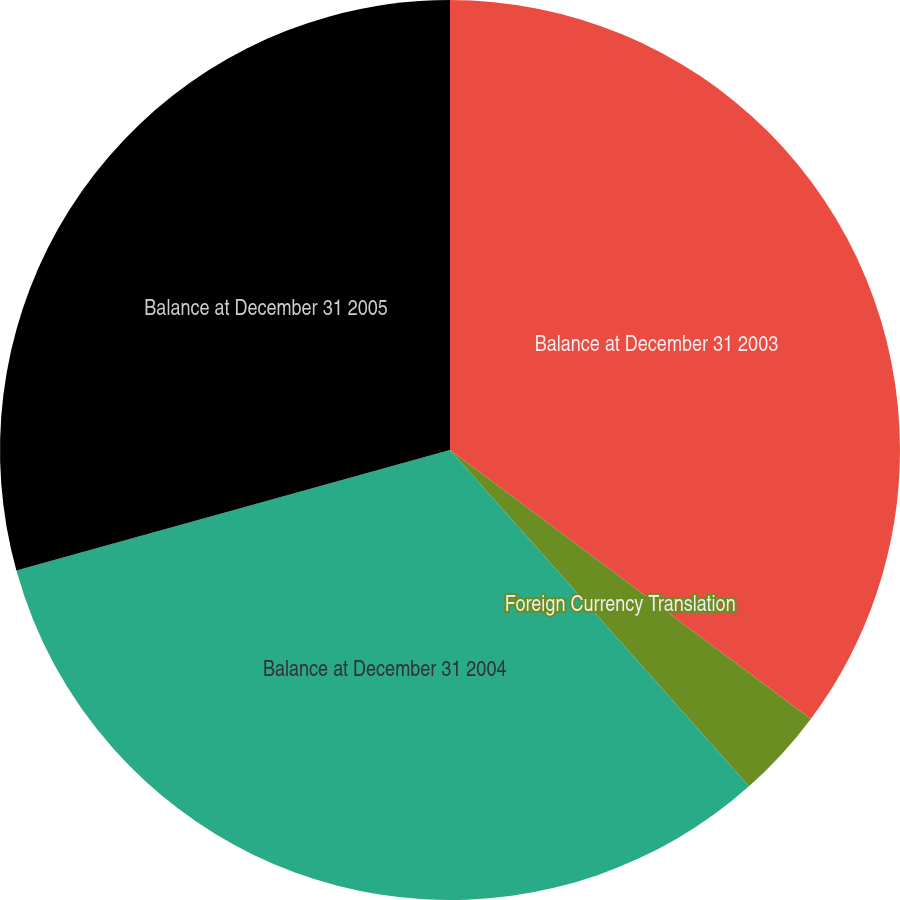Convert chart to OTSL. <chart><loc_0><loc_0><loc_500><loc_500><pie_chart><fcel>Balance at December 31 2003<fcel>Foreign Currency Translation<fcel>Balance at December 31 2004<fcel>Balance at December 31 2005<nl><fcel>35.19%<fcel>3.24%<fcel>32.25%<fcel>29.31%<nl></chart> 